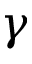Convert formula to latex. <formula><loc_0><loc_0><loc_500><loc_500>\gamma</formula> 